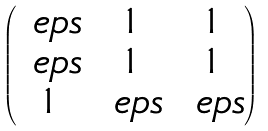<formula> <loc_0><loc_0><loc_500><loc_500>\begin{pmatrix} \ e p s & 1 & 1 \\ \ e p s & 1 & 1 \\ 1 & \ e p s & \ e p s \end{pmatrix}</formula> 